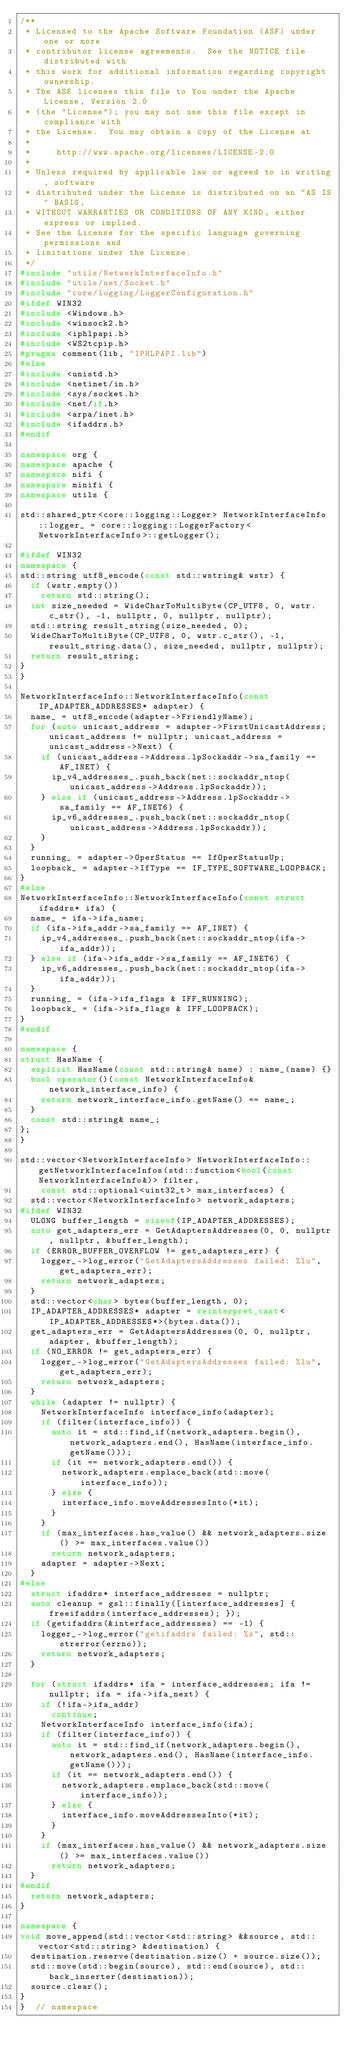<code> <loc_0><loc_0><loc_500><loc_500><_C++_>/**
 * Licensed to the Apache Software Foundation (ASF) under one or more
 * contributor license agreements.  See the NOTICE file distributed with
 * this work for additional information regarding copyright ownership.
 * The ASF licenses this file to You under the Apache License, Version 2.0
 * (the "License"); you may not use this file except in compliance with
 * the License.  You may obtain a copy of the License at
 *
 *     http://www.apache.org/licenses/LICENSE-2.0
 *
 * Unless required by applicable law or agreed to in writing, software
 * distributed under the License is distributed on an "AS IS" BASIS,
 * WITHOUT WARRANTIES OR CONDITIONS OF ANY KIND, either express or implied.
 * See the License for the specific language governing permissions and
 * limitations under the License.
 */
#include "utils/NetworkInterfaceInfo.h"
#include "utils/net/Socket.h"
#include "core/logging/LoggerConfiguration.h"
#ifdef WIN32
#include <Windows.h>
#include <winsock2.h>
#include <iphlpapi.h>
#include <WS2tcpip.h>
#pragma comment(lib, "IPHLPAPI.lib")
#else
#include <unistd.h>
#include <netinet/in.h>
#include <sys/socket.h>
#include <net/if.h>
#include <arpa/inet.h>
#include <ifaddrs.h>
#endif

namespace org {
namespace apache {
namespace nifi {
namespace minifi {
namespace utils {

std::shared_ptr<core::logging::Logger> NetworkInterfaceInfo::logger_ = core::logging::LoggerFactory<NetworkInterfaceInfo>::getLogger();

#ifdef WIN32
namespace {
std::string utf8_encode(const std::wstring& wstr) {
  if (wstr.empty())
    return std::string();
  int size_needed = WideCharToMultiByte(CP_UTF8, 0, wstr.c_str(), -1, nullptr, 0, nullptr, nullptr);
  std::string result_string(size_needed, 0);
  WideCharToMultiByte(CP_UTF8, 0, wstr.c_str(), -1, result_string.data(), size_needed, nullptr, nullptr);
  return result_string;
}
}

NetworkInterfaceInfo::NetworkInterfaceInfo(const IP_ADAPTER_ADDRESSES* adapter) {
  name_ = utf8_encode(adapter->FriendlyName);
  for (auto unicast_address = adapter->FirstUnicastAddress; unicast_address != nullptr; unicast_address = unicast_address->Next) {
    if (unicast_address->Address.lpSockaddr->sa_family == AF_INET) {
      ip_v4_addresses_.push_back(net::sockaddr_ntop(unicast_address->Address.lpSockaddr));
    } else if (unicast_address->Address.lpSockaddr->sa_family == AF_INET6) {
      ip_v6_addresses_.push_back(net::sockaddr_ntop(unicast_address->Address.lpSockaddr));
    }
  }
  running_ = adapter->OperStatus == IfOperStatusUp;
  loopback_ = adapter->IfType == IF_TYPE_SOFTWARE_LOOPBACK;
}
#else
NetworkInterfaceInfo::NetworkInterfaceInfo(const struct ifaddrs* ifa) {
  name_ = ifa->ifa_name;
  if (ifa->ifa_addr->sa_family == AF_INET) {
    ip_v4_addresses_.push_back(net::sockaddr_ntop(ifa->ifa_addr));
  } else if (ifa->ifa_addr->sa_family == AF_INET6) {
    ip_v6_addresses_.push_back(net::sockaddr_ntop(ifa->ifa_addr));
  }
  running_ = (ifa->ifa_flags & IFF_RUNNING);
  loopback_ = (ifa->ifa_flags & IFF_LOOPBACK);
}
#endif

namespace {
struct HasName {
  explicit HasName(const std::string& name) : name_(name) {}
  bool operator()(const NetworkInterfaceInfo& network_interface_info) {
    return network_interface_info.getName() == name_;
  }
  const std::string& name_;
};
}

std::vector<NetworkInterfaceInfo> NetworkInterfaceInfo::getNetworkInterfaceInfos(std::function<bool(const NetworkInterfaceInfo&)> filter,
    const std::optional<uint32_t> max_interfaces) {
  std::vector<NetworkInterfaceInfo> network_adapters;
#ifdef WIN32
  ULONG buffer_length = sizeof(IP_ADAPTER_ADDRESSES);
  auto get_adapters_err = GetAdaptersAddresses(0, 0, nullptr, nullptr, &buffer_length);
  if (ERROR_BUFFER_OVERFLOW != get_adapters_err) {
    logger_->log_error("GetAdaptersAddresses failed: %lu", get_adapters_err);
    return network_adapters;
  }
  std::vector<char> bytes(buffer_length, 0);
  IP_ADAPTER_ADDRESSES* adapter = reinterpret_cast<IP_ADAPTER_ADDRESSES*>(bytes.data());
  get_adapters_err = GetAdaptersAddresses(0, 0, nullptr, adapter, &buffer_length);
  if (NO_ERROR != get_adapters_err) {
    logger_->log_error("GetAdaptersAddresses failed: %lu", get_adapters_err);
    return network_adapters;
  }
  while (adapter != nullptr) {
    NetworkInterfaceInfo interface_info(adapter);
    if (filter(interface_info)) {
      auto it = std::find_if(network_adapters.begin(), network_adapters.end(), HasName(interface_info.getName()));
      if (it == network_adapters.end()) {
        network_adapters.emplace_back(std::move(interface_info));
      } else {
        interface_info.moveAddressesInto(*it);
      }
    }
    if (max_interfaces.has_value() && network_adapters.size() >= max_interfaces.value())
      return network_adapters;
    adapter = adapter->Next;
  }
#else
  struct ifaddrs* interface_addresses = nullptr;
  auto cleanup = gsl::finally([interface_addresses] { freeifaddrs(interface_addresses); });
  if (getifaddrs(&interface_addresses) == -1) {
    logger_->log_error("getifaddrs failed: %s", std::strerror(errno));
    return network_adapters;
  }

  for (struct ifaddrs* ifa = interface_addresses; ifa != nullptr; ifa = ifa->ifa_next) {
    if (!ifa->ifa_addr)
      continue;
    NetworkInterfaceInfo interface_info(ifa);
    if (filter(interface_info)) {
      auto it = std::find_if(network_adapters.begin(), network_adapters.end(), HasName(interface_info.getName()));
      if (it == network_adapters.end()) {
        network_adapters.emplace_back(std::move(interface_info));
      } else {
        interface_info.moveAddressesInto(*it);
      }
    }
    if (max_interfaces.has_value() && network_adapters.size() >= max_interfaces.value())
      return network_adapters;
  }
#endif
  return network_adapters;
}

namespace {
void move_append(std::vector<std::string> &&source, std::vector<std::string> &destination) {
  destination.reserve(destination.size() + source.size());
  std::move(std::begin(source), std::end(source), std::back_inserter(destination));
  source.clear();
}
}  // namespace
</code> 